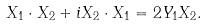Convert formula to latex. <formula><loc_0><loc_0><loc_500><loc_500>X _ { 1 } \cdot X _ { 2 } + i X _ { 2 } \cdot X _ { 1 } = 2 Y _ { 1 } X _ { 2 } .</formula> 